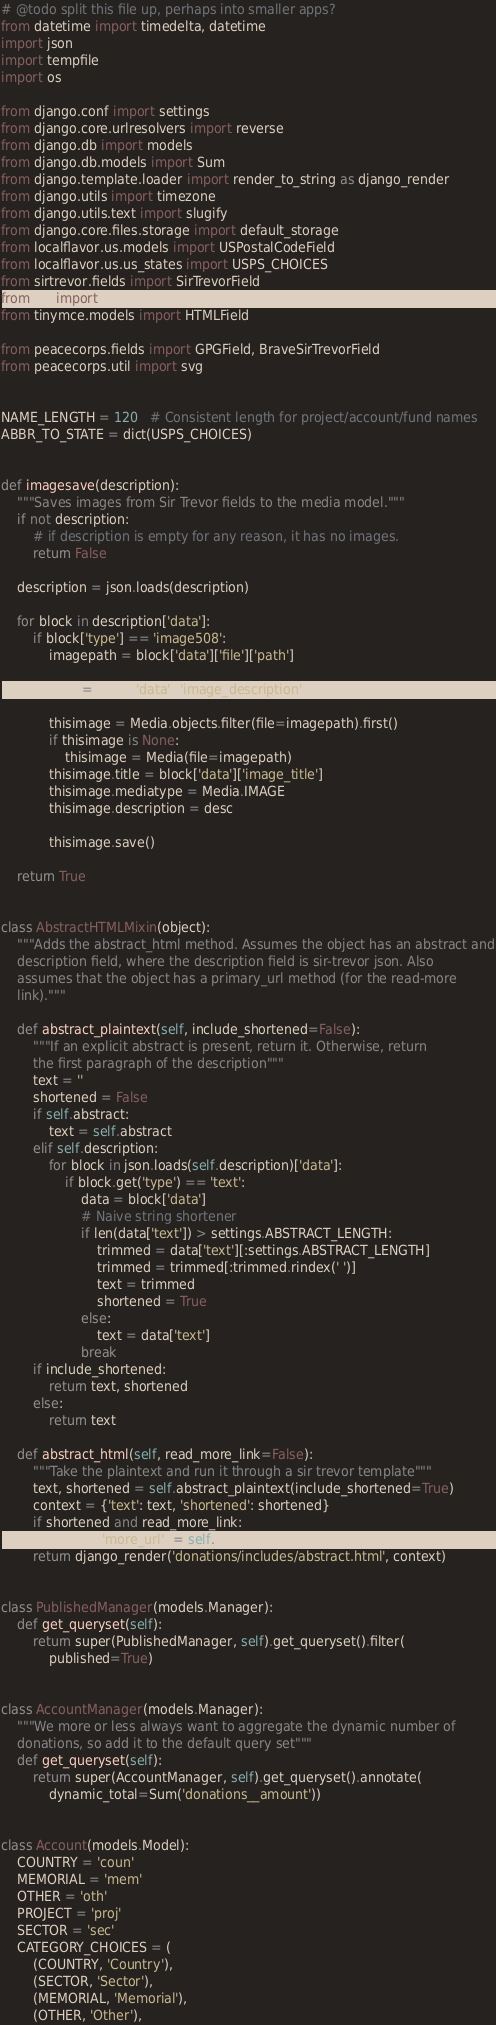Convert code to text. <code><loc_0><loc_0><loc_500><loc_500><_Python_># @todo split this file up, perhaps into smaller apps?
from datetime import timedelta, datetime
import json
import tempfile
import os

from django.conf import settings
from django.core.urlresolvers import reverse
from django.db import models
from django.db.models import Sum
from django.template.loader import render_to_string as django_render
from django.utils import timezone
from django.utils.text import slugify
from django.core.files.storage import default_storage
from localflavor.us.models import USPostalCodeField
from localflavor.us.us_states import USPS_CHOICES
from sirtrevor.fields import SirTrevorField
from PIL import Image
from tinymce.models import HTMLField

from peacecorps.fields import GPGField, BraveSirTrevorField
from peacecorps.util import svg


NAME_LENGTH = 120   # Consistent length for project/account/fund names
ABBR_TO_STATE = dict(USPS_CHOICES)


def imagesave(description):
    """Saves images from Sir Trevor fields to the media model."""
    if not description:
        # if description is empty for any reason, it has no images.
        return False

    description = json.loads(description)

    for block in description['data']:
        if block['type'] == 'image508':
            imagepath = block['data']['file']['path']

            desc = block['data']['image_description']

            thisimage = Media.objects.filter(file=imagepath).first()
            if thisimage is None:
                thisimage = Media(file=imagepath)
            thisimage.title = block['data']['image_title']
            thisimage.mediatype = Media.IMAGE
            thisimage.description = desc

            thisimage.save()

    return True


class AbstractHTMLMixin(object):
    """Adds the abstract_html method. Assumes the object has an abstract and
    description field, where the description field is sir-trevor json. Also
    assumes that the object has a primary_url method (for the read-more
    link)."""

    def abstract_plaintext(self, include_shortened=False):
        """If an explicit abstract is present, return it. Otherwise, return
        the first paragraph of the description"""
        text = ''
        shortened = False
        if self.abstract:
            text = self.abstract
        elif self.description:
            for block in json.loads(self.description)['data']:
                if block.get('type') == 'text':
                    data = block['data']
                    # Naive string shortener
                    if len(data['text']) > settings.ABSTRACT_LENGTH:
                        trimmed = data['text'][:settings.ABSTRACT_LENGTH]
                        trimmed = trimmed[:trimmed.rindex(' ')]
                        text = trimmed
                        shortened = True
                    else:
                        text = data['text']
                    break
        if include_shortened:
            return text, shortened
        else:
            return text

    def abstract_html(self, read_more_link=False):
        """Take the plaintext and run it through a sir trevor template"""
        text, shortened = self.abstract_plaintext(include_shortened=True)
        context = {'text': text, 'shortened': shortened}
        if shortened and read_more_link:
            context['more_url'] = self.primary_url()
        return django_render('donations/includes/abstract.html', context)


class PublishedManager(models.Manager):
    def get_queryset(self):
        return super(PublishedManager, self).get_queryset().filter(
            published=True)


class AccountManager(models.Manager):
    """We more or less always want to aggregate the dynamic number of
    donations, so add it to the default query set"""
    def get_queryset(self):
        return super(AccountManager, self).get_queryset().annotate(
            dynamic_total=Sum('donations__amount'))


class Account(models.Model):
    COUNTRY = 'coun'
    MEMORIAL = 'mem'
    OTHER = 'oth'
    PROJECT = 'proj'
    SECTOR = 'sec'
    CATEGORY_CHOICES = (
        (COUNTRY, 'Country'),
        (SECTOR, 'Sector'),
        (MEMORIAL, 'Memorial'),
        (OTHER, 'Other'),</code> 